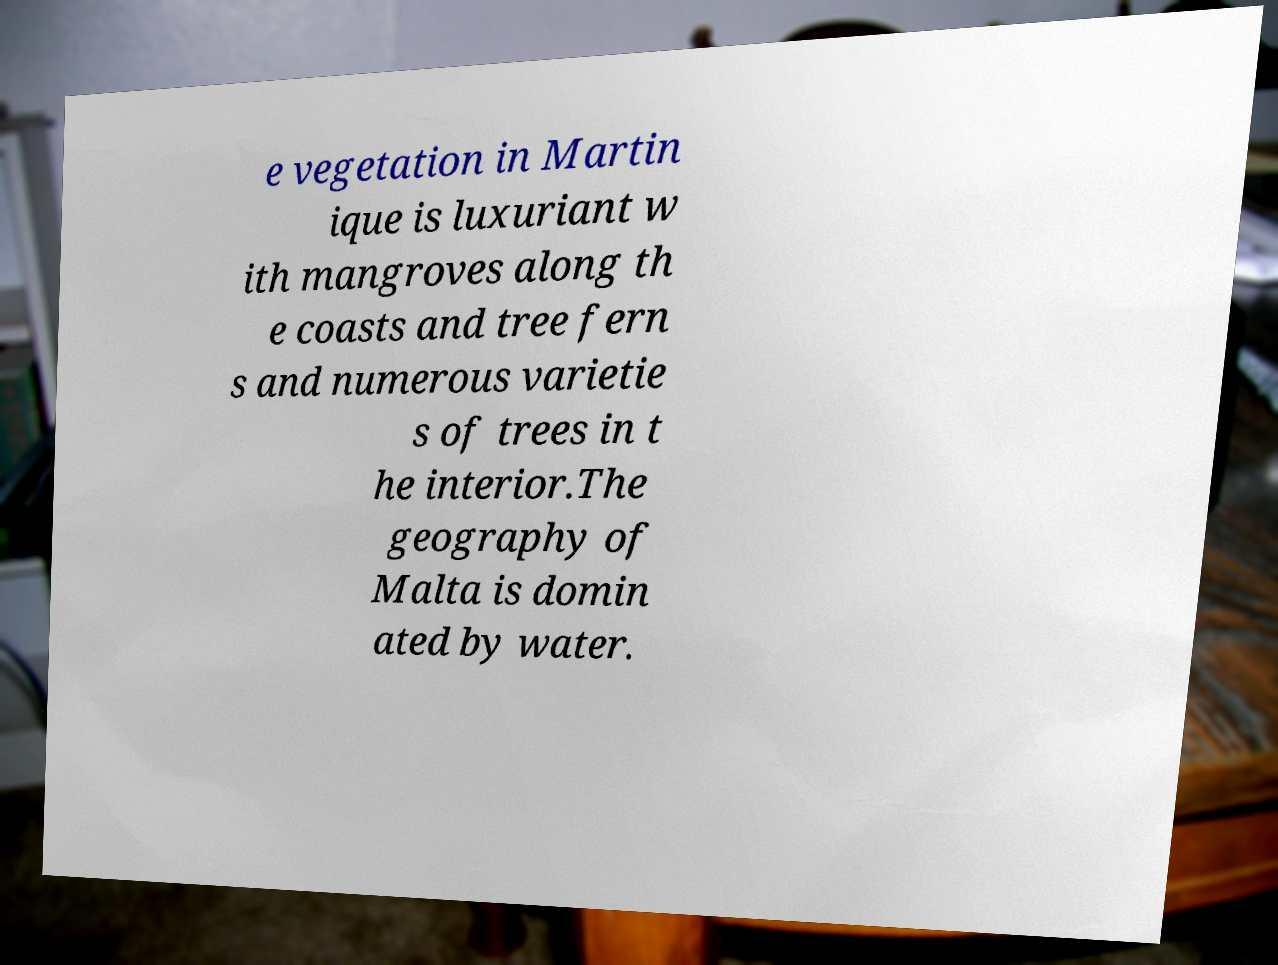Could you assist in decoding the text presented in this image and type it out clearly? e vegetation in Martin ique is luxuriant w ith mangroves along th e coasts and tree fern s and numerous varietie s of trees in t he interior.The geography of Malta is domin ated by water. 